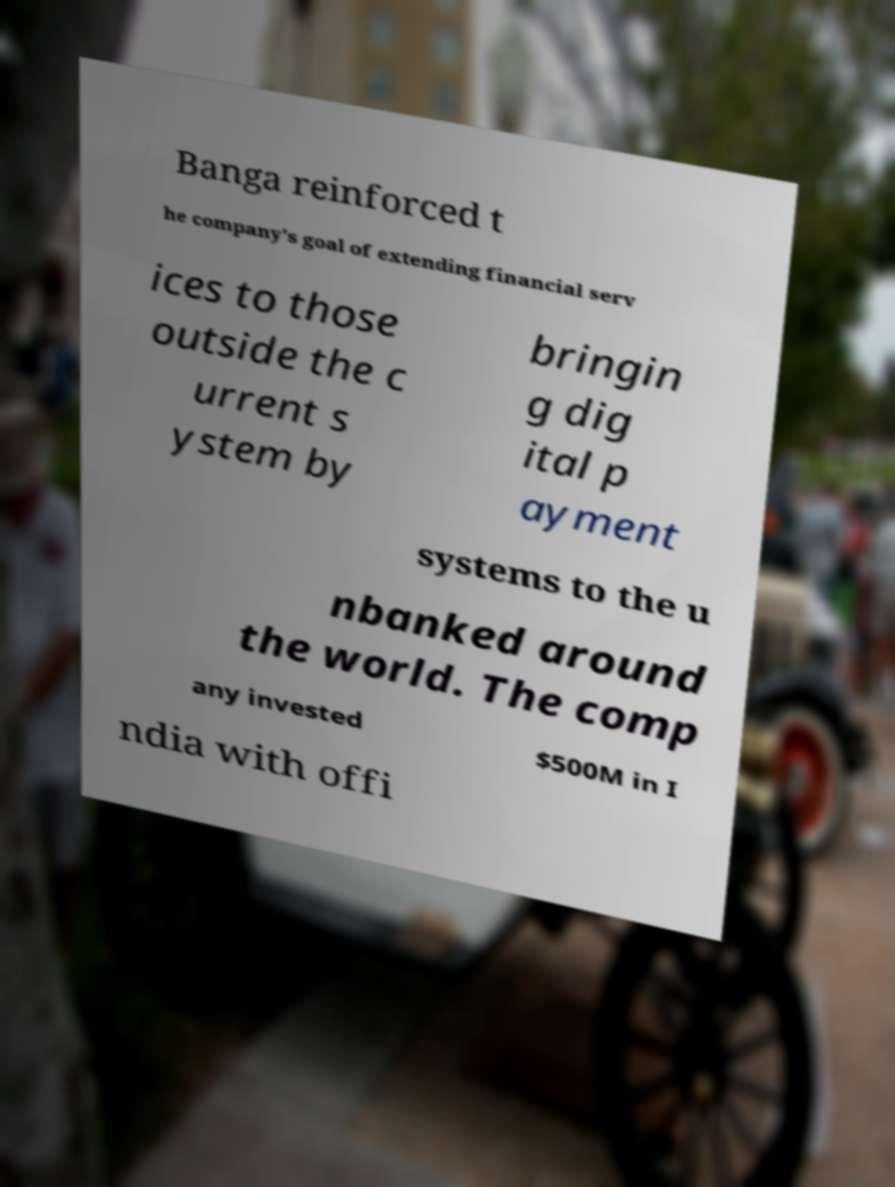I need the written content from this picture converted into text. Can you do that? Banga reinforced t he company's goal of extending financial serv ices to those outside the c urrent s ystem by bringin g dig ital p ayment systems to the u nbanked around the world. The comp any invested $500M in I ndia with offi 